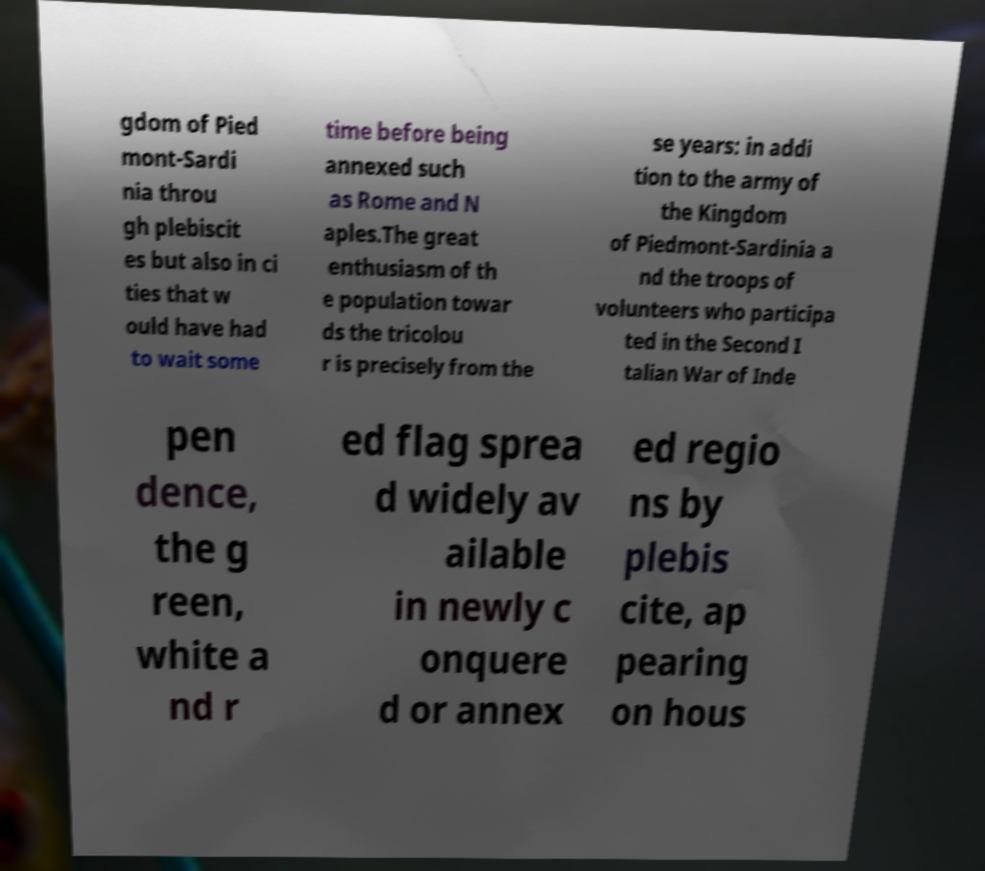Please identify and transcribe the text found in this image. gdom of Pied mont-Sardi nia throu gh plebiscit es but also in ci ties that w ould have had to wait some time before being annexed such as Rome and N aples.The great enthusiasm of th e population towar ds the tricolou r is precisely from the se years: in addi tion to the army of the Kingdom of Piedmont-Sardinia a nd the troops of volunteers who participa ted in the Second I talian War of Inde pen dence, the g reen, white a nd r ed flag sprea d widely av ailable in newly c onquere d or annex ed regio ns by plebis cite, ap pearing on hous 